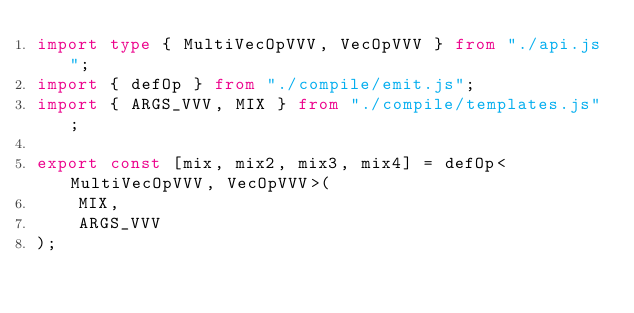Convert code to text. <code><loc_0><loc_0><loc_500><loc_500><_TypeScript_>import type { MultiVecOpVVV, VecOpVVV } from "./api.js";
import { defOp } from "./compile/emit.js";
import { ARGS_VVV, MIX } from "./compile/templates.js";

export const [mix, mix2, mix3, mix4] = defOp<MultiVecOpVVV, VecOpVVV>(
    MIX,
    ARGS_VVV
);
</code> 